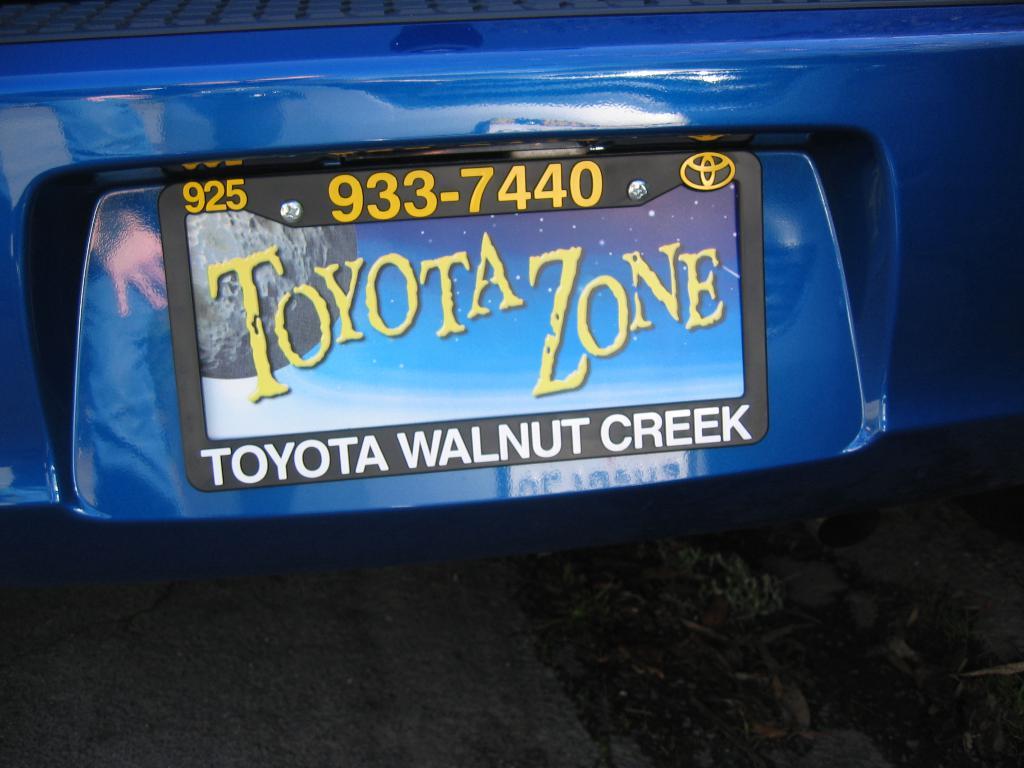Which toyota dealership is this from?
Give a very brief answer. Walnut creek. 